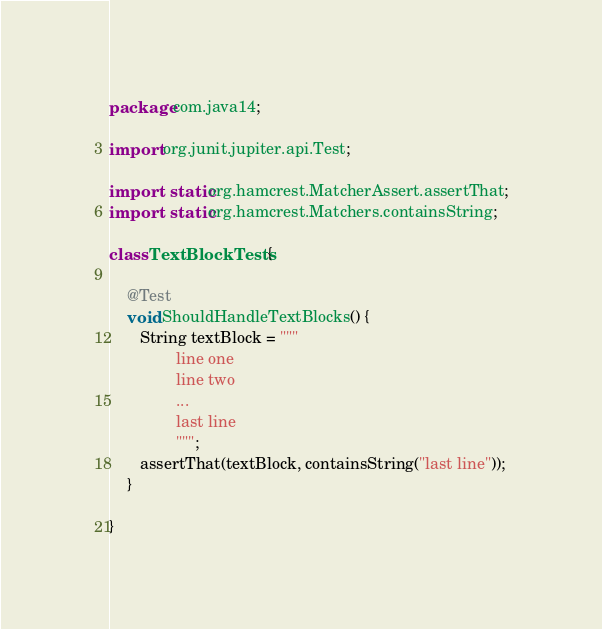Convert code to text. <code><loc_0><loc_0><loc_500><loc_500><_Java_>package com.java14;

import org.junit.jupiter.api.Test;

import static org.hamcrest.MatcherAssert.assertThat;
import static org.hamcrest.Matchers.containsString;

class TextBlockTests {

    @Test
    void ShouldHandleTextBlocks() {
       String textBlock = """
               line one
               line two 
               ...
               last line
               """;
       assertThat(textBlock, containsString("last line"));
    }

}
</code> 